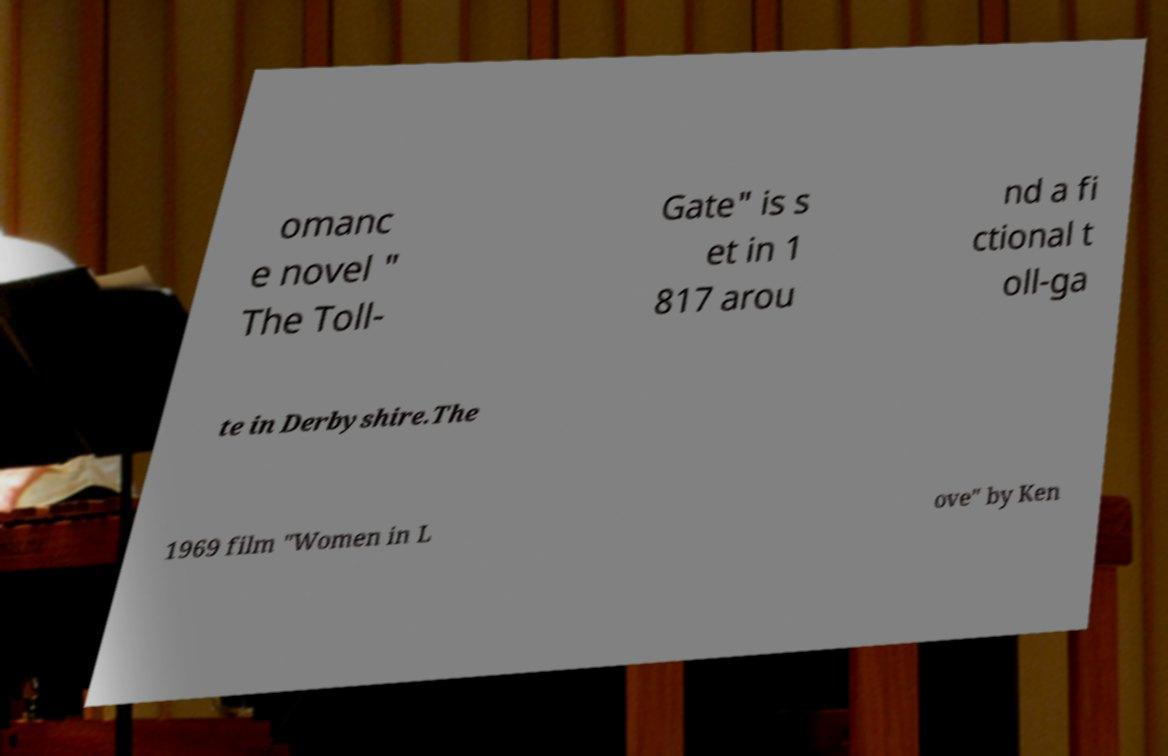Can you read and provide the text displayed in the image?This photo seems to have some interesting text. Can you extract and type it out for me? omanc e novel " The Toll- Gate" is s et in 1 817 arou nd a fi ctional t oll-ga te in Derbyshire.The 1969 film "Women in L ove" by Ken 